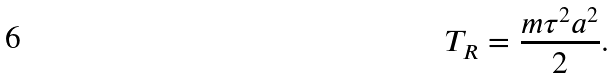Convert formula to latex. <formula><loc_0><loc_0><loc_500><loc_500>T _ { R } = \frac { m \tau ^ { 2 } a ^ { 2 } } { 2 } .</formula> 